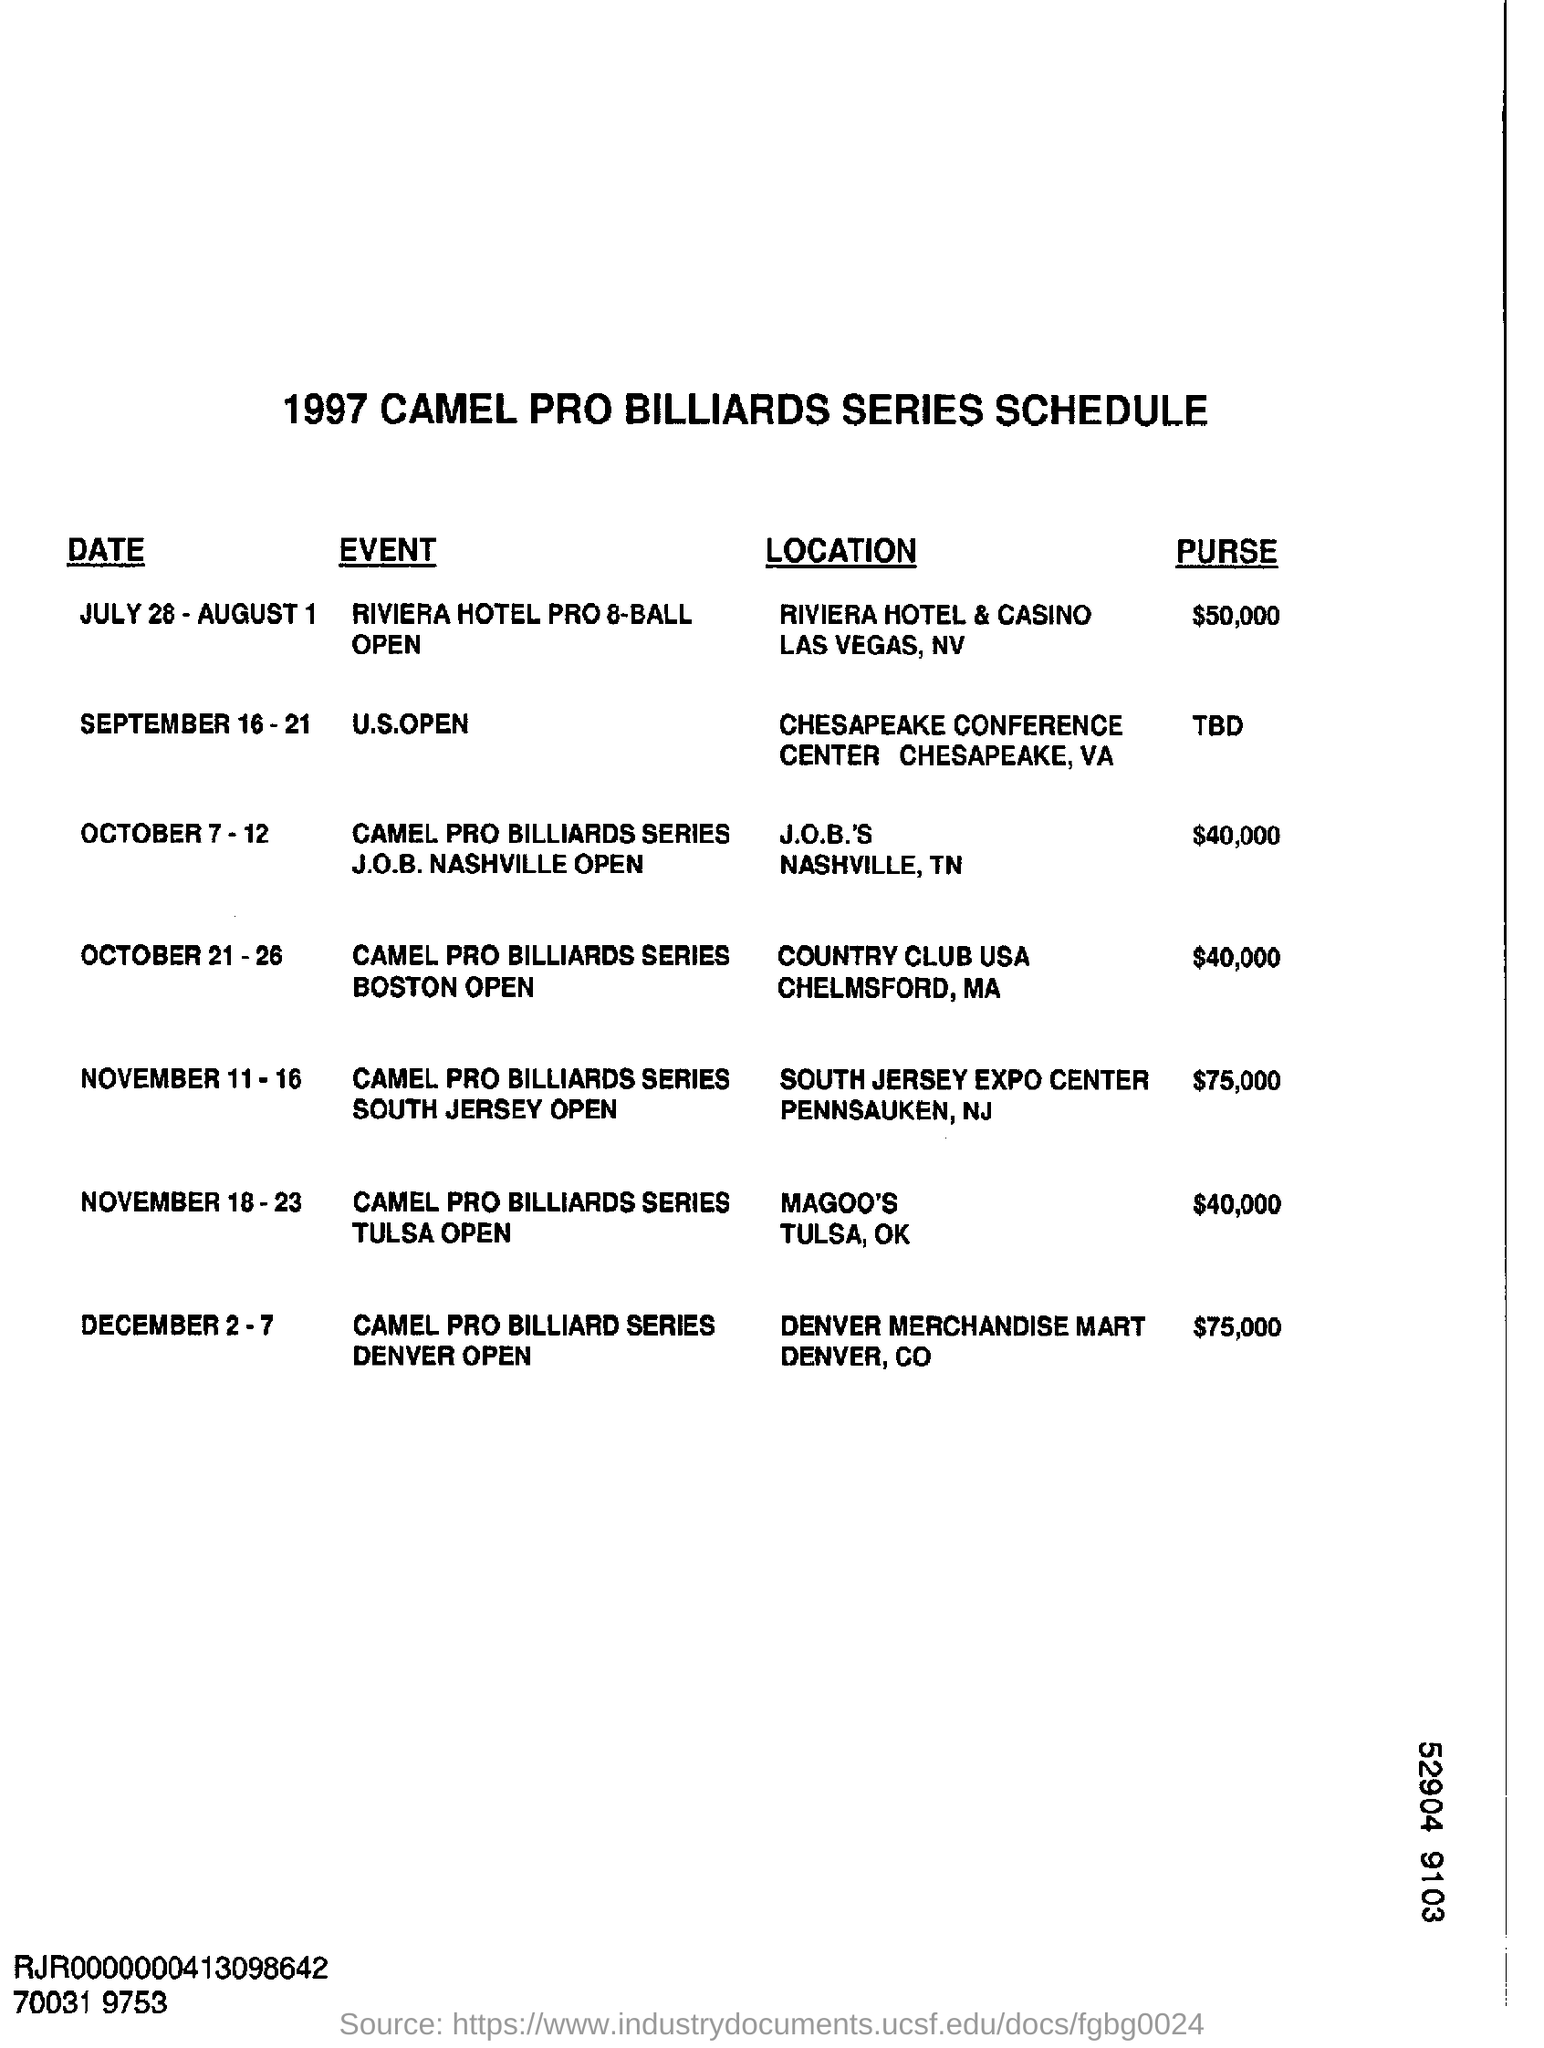What is the Title of the document ?
Your answer should be very brief. 1997 CAMEL PRO BILLIARDS SERIES SCHEDULE. When was U.S.OPEN Event  Conducted ?
Ensure brevity in your answer.  SEPTEMBER 16-21. 